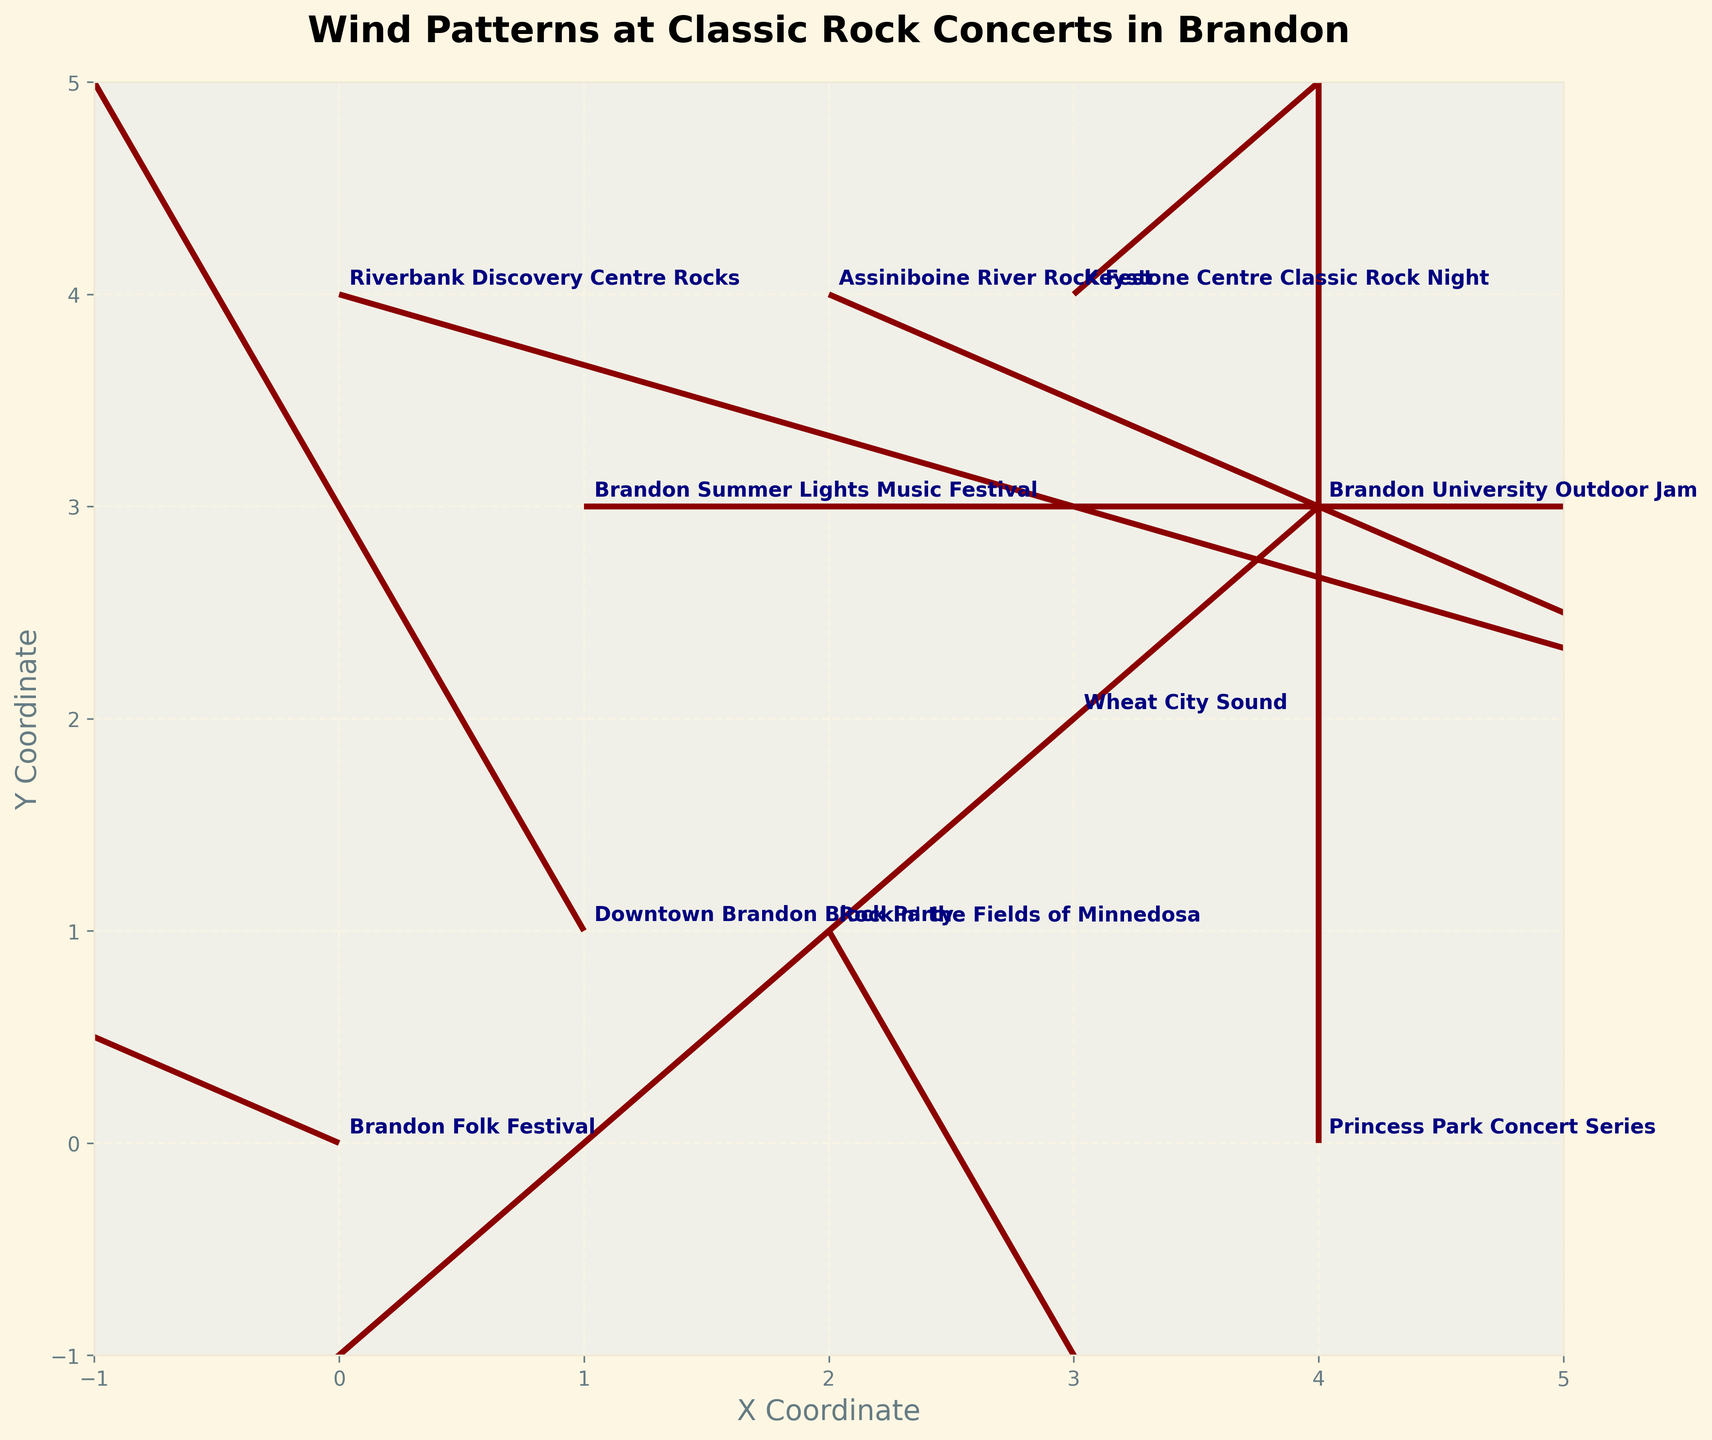What's the title of the plot? The title of the plot is generally displayed at the top center of the figure. In this quiver plot, looking at the top center, you will see the title "Wind Patterns at Classic Rock Concerts in Brandon".
Answer: Wind Patterns at Classic Rock Concerts in Brandon How many classic rock concert events are annotated in the plot? You can count the number of events annotated near the arrows. Each annotation near the arrow represents a different event. By counting the annotations, you find there are 10 events marked in the plot.
Answer: 10 Which event has a wind vector pointing directly upwards? To determine which event has a wind vector pointing directly upwards, look for an arrow with no horizontal component (u=0) and a positive vertical component (v>0). The only vector pointing directly up is at (4,0) with (u=0, v=2), corresponding to the "Princess Park Concert Series".
Answer: Princess Park Concert Series What is the direction of the wind at the "Downtown Brandon Block Party"? The wind direction can be determined by the components (u, v). For the "Downtown Brandon Block Party" at (1, 1), the vector is (-1, 2). It points northwestward (negative x-direction) and upward (positive y-direction).
Answer: Northwest and Upward Which event has the strongest wind speed and what is the value? To find the strongest wind speed, calculate the magnitude of each vector using the formula sqrt(u^2 + v^2). The necessary calculations show that the event at (4, 3) "Brandon University Outdoor Jam" with vector (-2, -2) has the largest magnitude, sqrt((-2)^2 + (-2)^2) = sqrt(8) ≈ 2.83.
Answer: Brandon University Outdoor Jam, ≈ 2.83 What's the average x-component of the wind vectors at all events? Add the x-components (u values) of all vectors and divide by the total number of events. The sum of x-components = -2 + 1 + 3 - 1 + 0 + 2 - 1 + 1 - 2 + 3 = 4. So, the average = 4 / 10 = 0.4.
Answer: 0.4 Which event's wind vector is shortest and how did you find it? Calculate the magnitude of each vector using the formula sqrt(u^2 + v^2). The shortest vector is at (3,2) "Wheat City Sound" with vector (-1, -1) having a magnitude sqrt((-1)^2 + (-1)^2) = sqrt(2) ≈ 1.41.
Answer: Wheat City Sound, ≈ 1.41 Compare the wind vectors between "Riverbank Discovery Centre Rocks" and "Rockin' the Fields of Minnedosa". Which one has a stronger wind and by how much? Compute the magnitudes of both vectors: "Riverbank Discovery Centre Rocks": sqrt((3)^2 + (-1)^2) = sqrt(10) ≈ 3.16. "Rockin' the Fields of Minnedosa": sqrt((1)^2 + (-2)^2) = sqrt(5) ≈ 2.24. The wind at "Riverbank Discovery Centre Rocks" is stronger by 3.16 - 2.24 ≈ 0.92.
Answer: Riverbank Discovery Centre Rocks by ≈ 0.92 